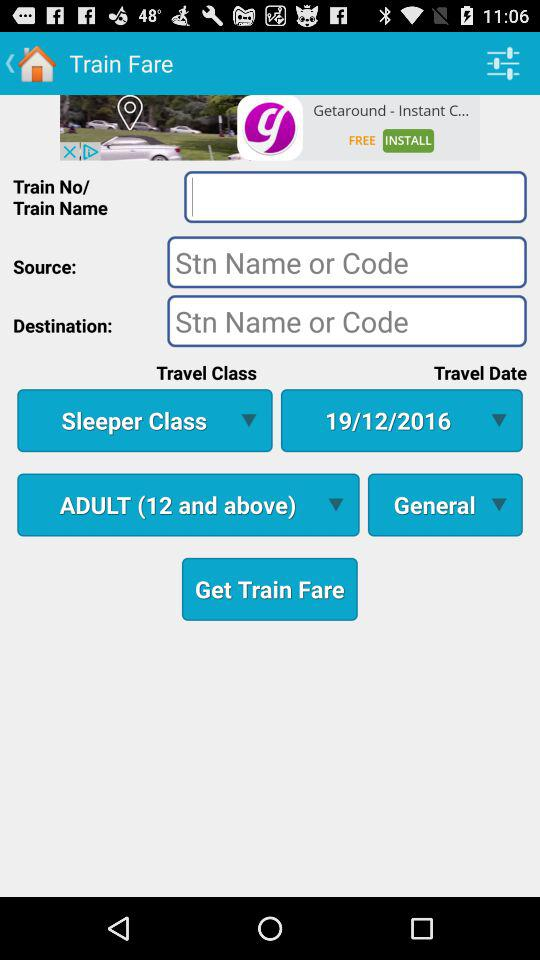What is the selected type of compartment? The selected type of compartment is "General". 